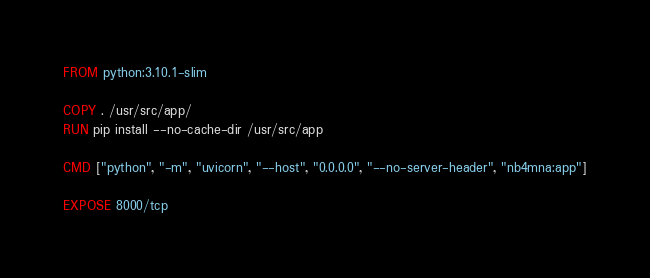<code> <loc_0><loc_0><loc_500><loc_500><_Dockerfile_>FROM python:3.10.1-slim

COPY . /usr/src/app/
RUN pip install --no-cache-dir /usr/src/app

CMD ["python", "-m", "uvicorn", "--host", "0.0.0.0", "--no-server-header", "nb4mna:app"]

EXPOSE 8000/tcp</code> 